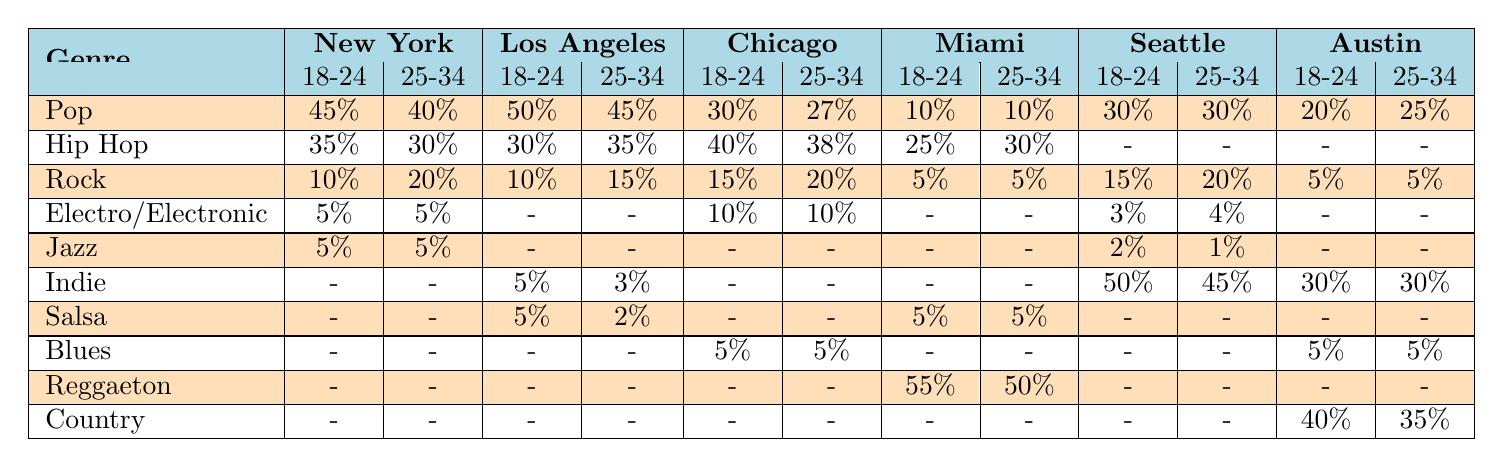What is the popularity percentage of Pop music in Miami for the age group 18-24? According to the table, the popularity percentage of Pop music in Miami for the age group 18-24 is listed as 10%.
Answer: 10% Which music genre has the highest popularity in Los Angeles among the 25-34 age group? The table shows that Pop has the highest popularity at 45% for the 25-34 age group in Los Angeles, compared to Hip Hop at 35% and Rock at 15%.
Answer: Pop Is there any age group in Chicago where Blues music is popular? The table indicates Blues music has a popularity value of 5% for the age group 18-24 and 5% for 25-34 in Chicago, confirming that Blues is popular in both age groups.
Answer: Yes Which city shows the highest percentage of Reggaeton popularity for the age group 18-24? The table shows that Miami has the highest percentage of Reggaeton popularity at 55% for the 18-24 age group, compared to 0% in all other cities listed.
Answer: Miami In Seattle, what is the combined popularity of Indie and Pop for the 25-34 age group? For the 25-34 age group in Seattle, Indie has a popularity percentage of 45%, and Pop has 30%. Adding these gives 45% + 30% = 75%.
Answer: 75% Which city has the lowest popularity percentage for Rock music in both age groups? By comparing the percentages, Austin and Miami both have the lowest popularity of Rock music at 5% for the age group 18-24 and 25-34.
Answer: Austin and Miami What is the difference in popularity percentage for Hip Hop music between the 18-24 and 25-34 age groups in New York? The table shows Hip Hop's popularity is 35% for the 18-24 age group and 30% for the 25-34 age group in New York. The difference is 35% - 30% = 5%.
Answer: 5% Is there any age group in Los Angeles that doesn't have Hip Hop listed? According to the table, Hip Hop is listed for both age groups (18-24 at 30% and 25-34 at 35%) in Los Angeles, meaning there are no age groups without it.
Answer: No How does the popularity of Electronic music in Chicago compare to that in Seattle for the 25-34 age group? The table states that Electronic music is at 10% for Chicago and 4% for Seattle in the 25-34 age group. Chicago has a higher popularity of 10% compared to Seattle's 4%.
Answer: Chicago What genre has the most balanced popularity between the two age groups in New York? Reviewing the table, Pop (40% and 45%) has the most balanced popularity, with a difference of only 5%, which is the smallest compared to other genres.
Answer: Pop 